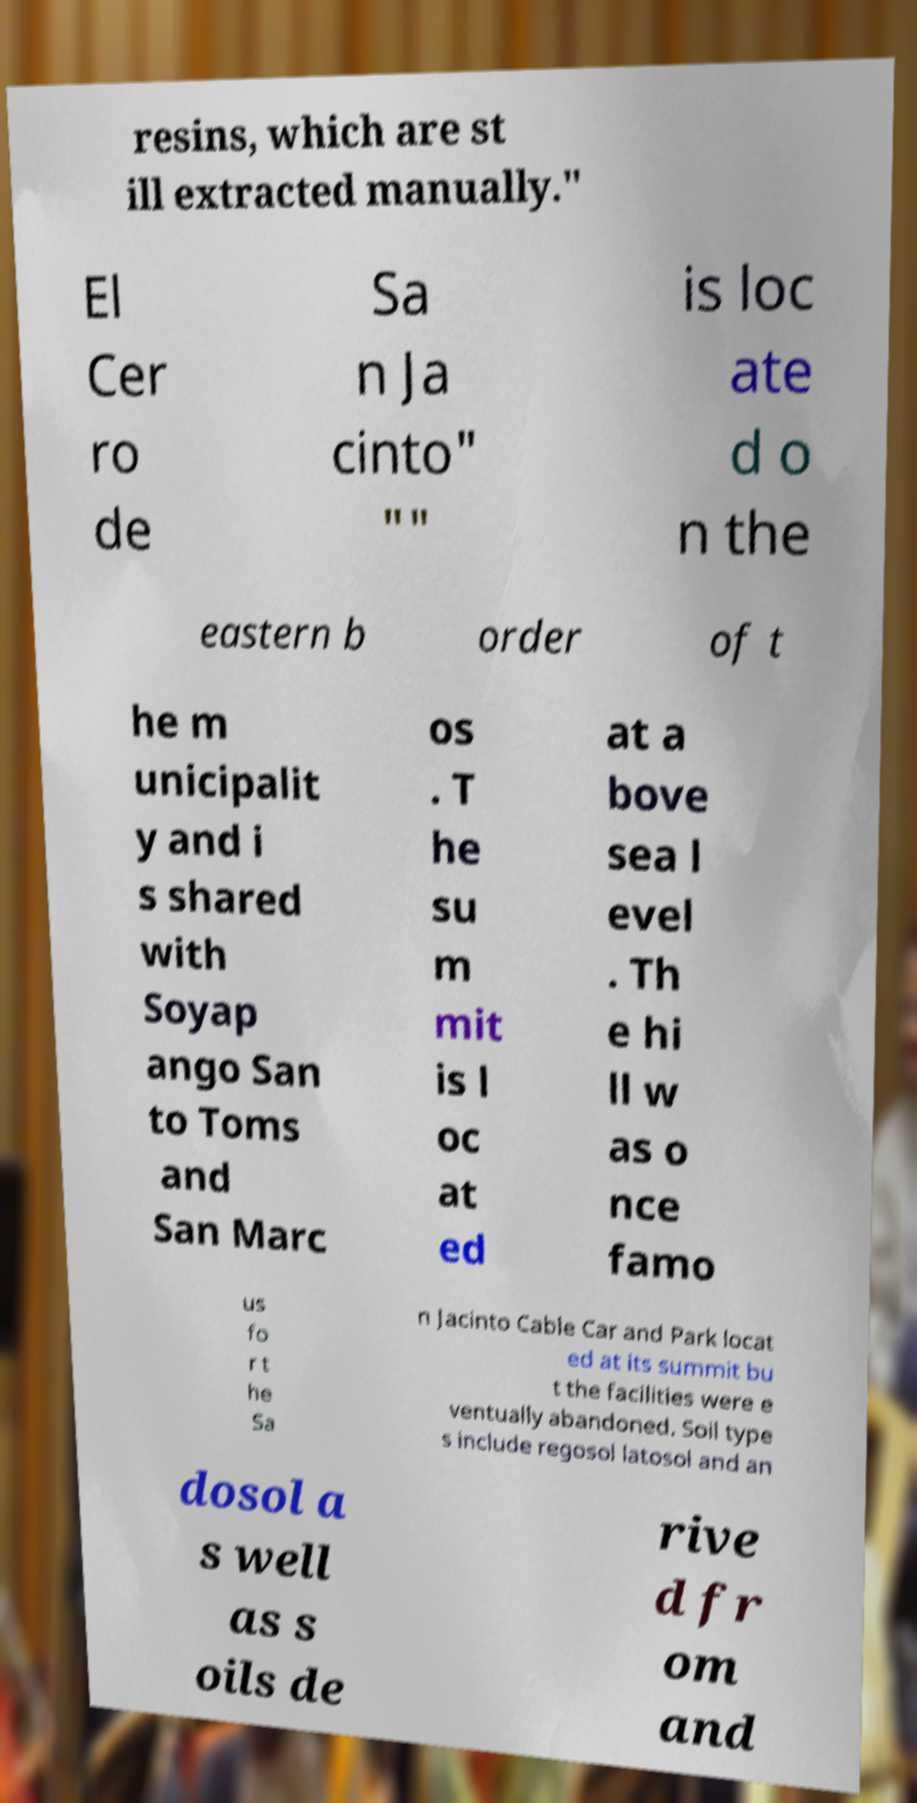I need the written content from this picture converted into text. Can you do that? resins, which are st ill extracted manually." El Cer ro de Sa n Ja cinto" "" is loc ate d o n the eastern b order of t he m unicipalit y and i s shared with Soyap ango San to Toms and San Marc os . T he su m mit is l oc at ed at a bove sea l evel . Th e hi ll w as o nce famo us fo r t he Sa n Jacinto Cable Car and Park locat ed at its summit bu t the facilities were e ventually abandoned. Soil type s include regosol latosol and an dosol a s well as s oils de rive d fr om and 